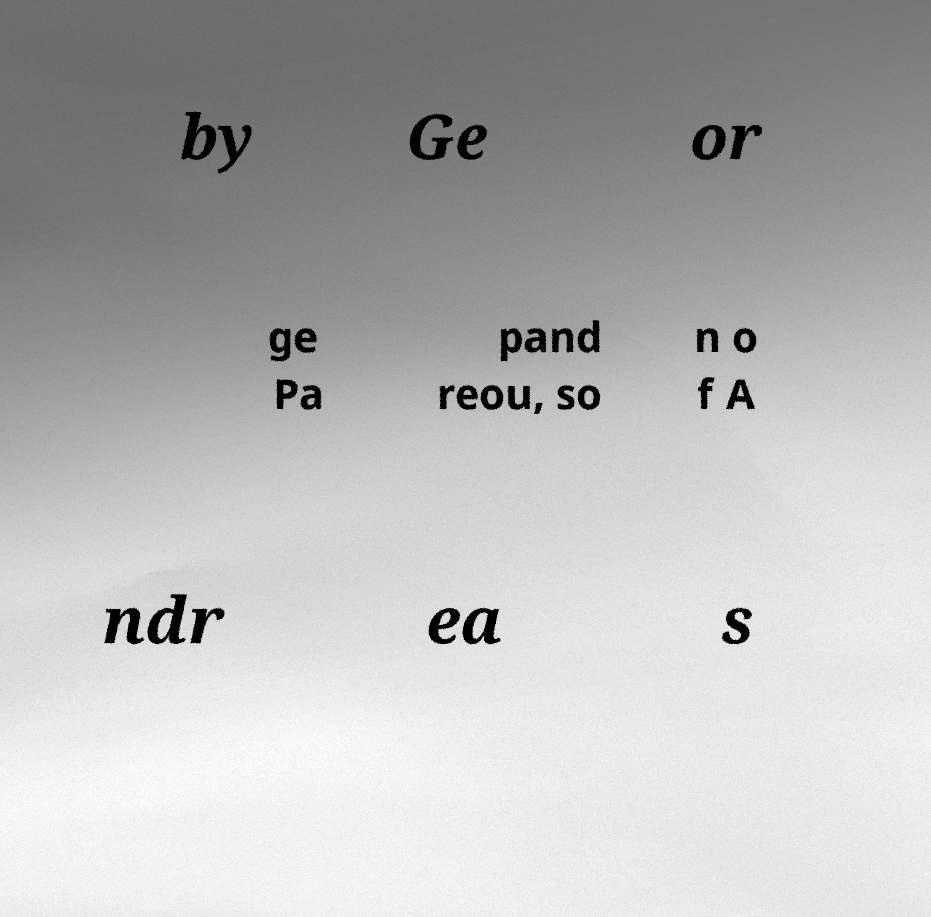There's text embedded in this image that I need extracted. Can you transcribe it verbatim? by Ge or ge Pa pand reou, so n o f A ndr ea s 